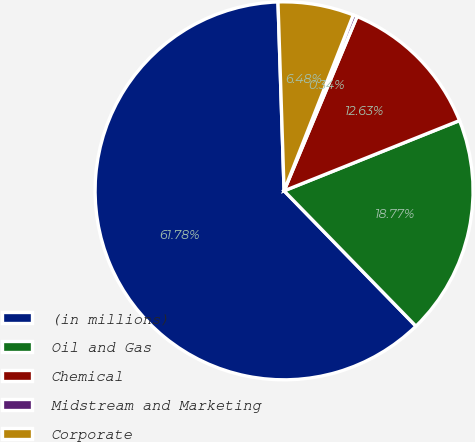Convert chart. <chart><loc_0><loc_0><loc_500><loc_500><pie_chart><fcel>(in millions)<fcel>Oil and Gas<fcel>Chemical<fcel>Midstream and Marketing<fcel>Corporate<nl><fcel>61.78%<fcel>18.77%<fcel>12.63%<fcel>0.34%<fcel>6.48%<nl></chart> 